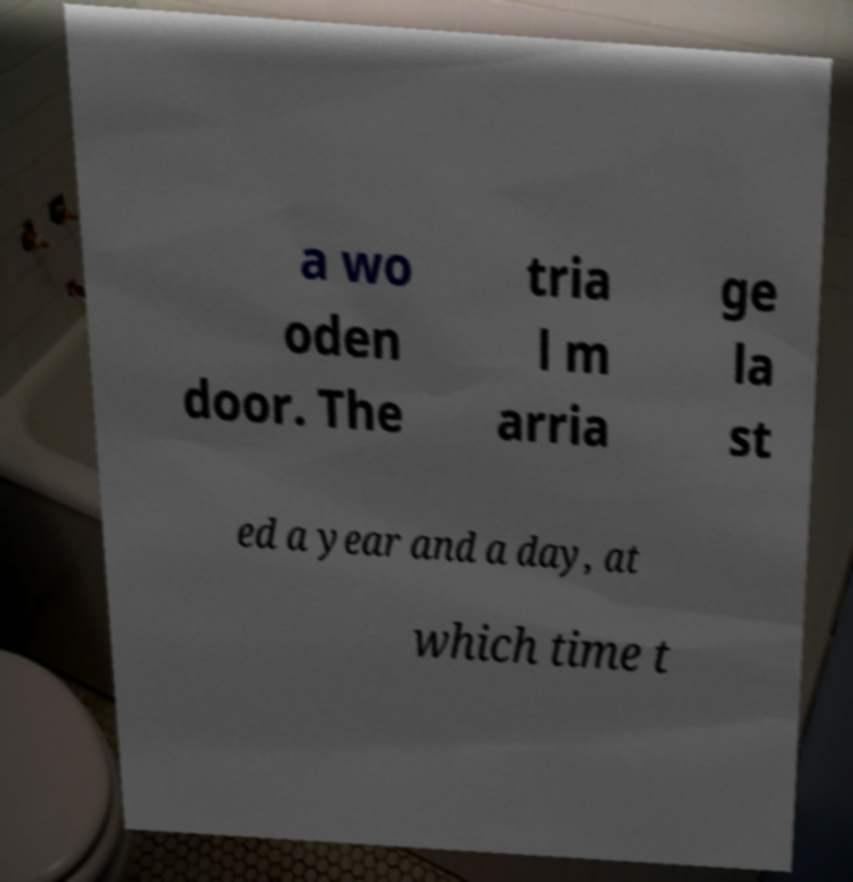Please identify and transcribe the text found in this image. a wo oden door. The tria l m arria ge la st ed a year and a day, at which time t 